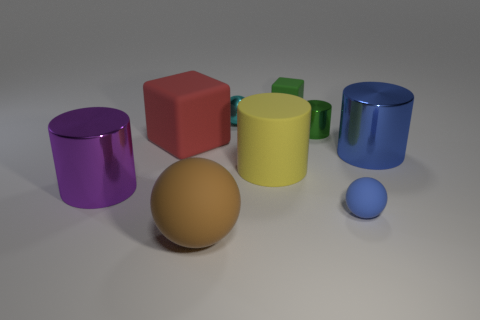Are there any shadows present in this image that give clues about the light source? Yes, the objects in the image cast shadows toward the bottom right, suggesting that the light source is positioned to the upper left side of the scene. The shadows have soft edges, which indicates that the light source might be somewhat diffused, like natural daylight or a larger artificial light. 